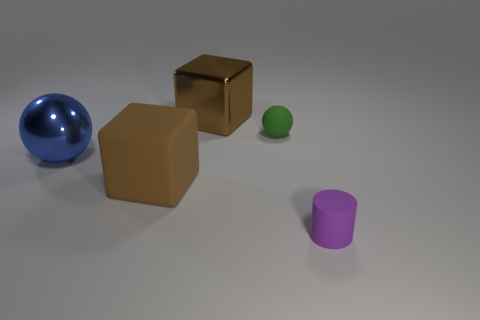Add 3 large yellow cylinders. How many objects exist? 8 Subtract all cylinders. How many objects are left? 4 Add 3 large blocks. How many large blocks exist? 5 Subtract 0 yellow blocks. How many objects are left? 5 Subtract all tiny purple rubber cylinders. Subtract all blue cylinders. How many objects are left? 4 Add 3 brown metallic cubes. How many brown metallic cubes are left? 4 